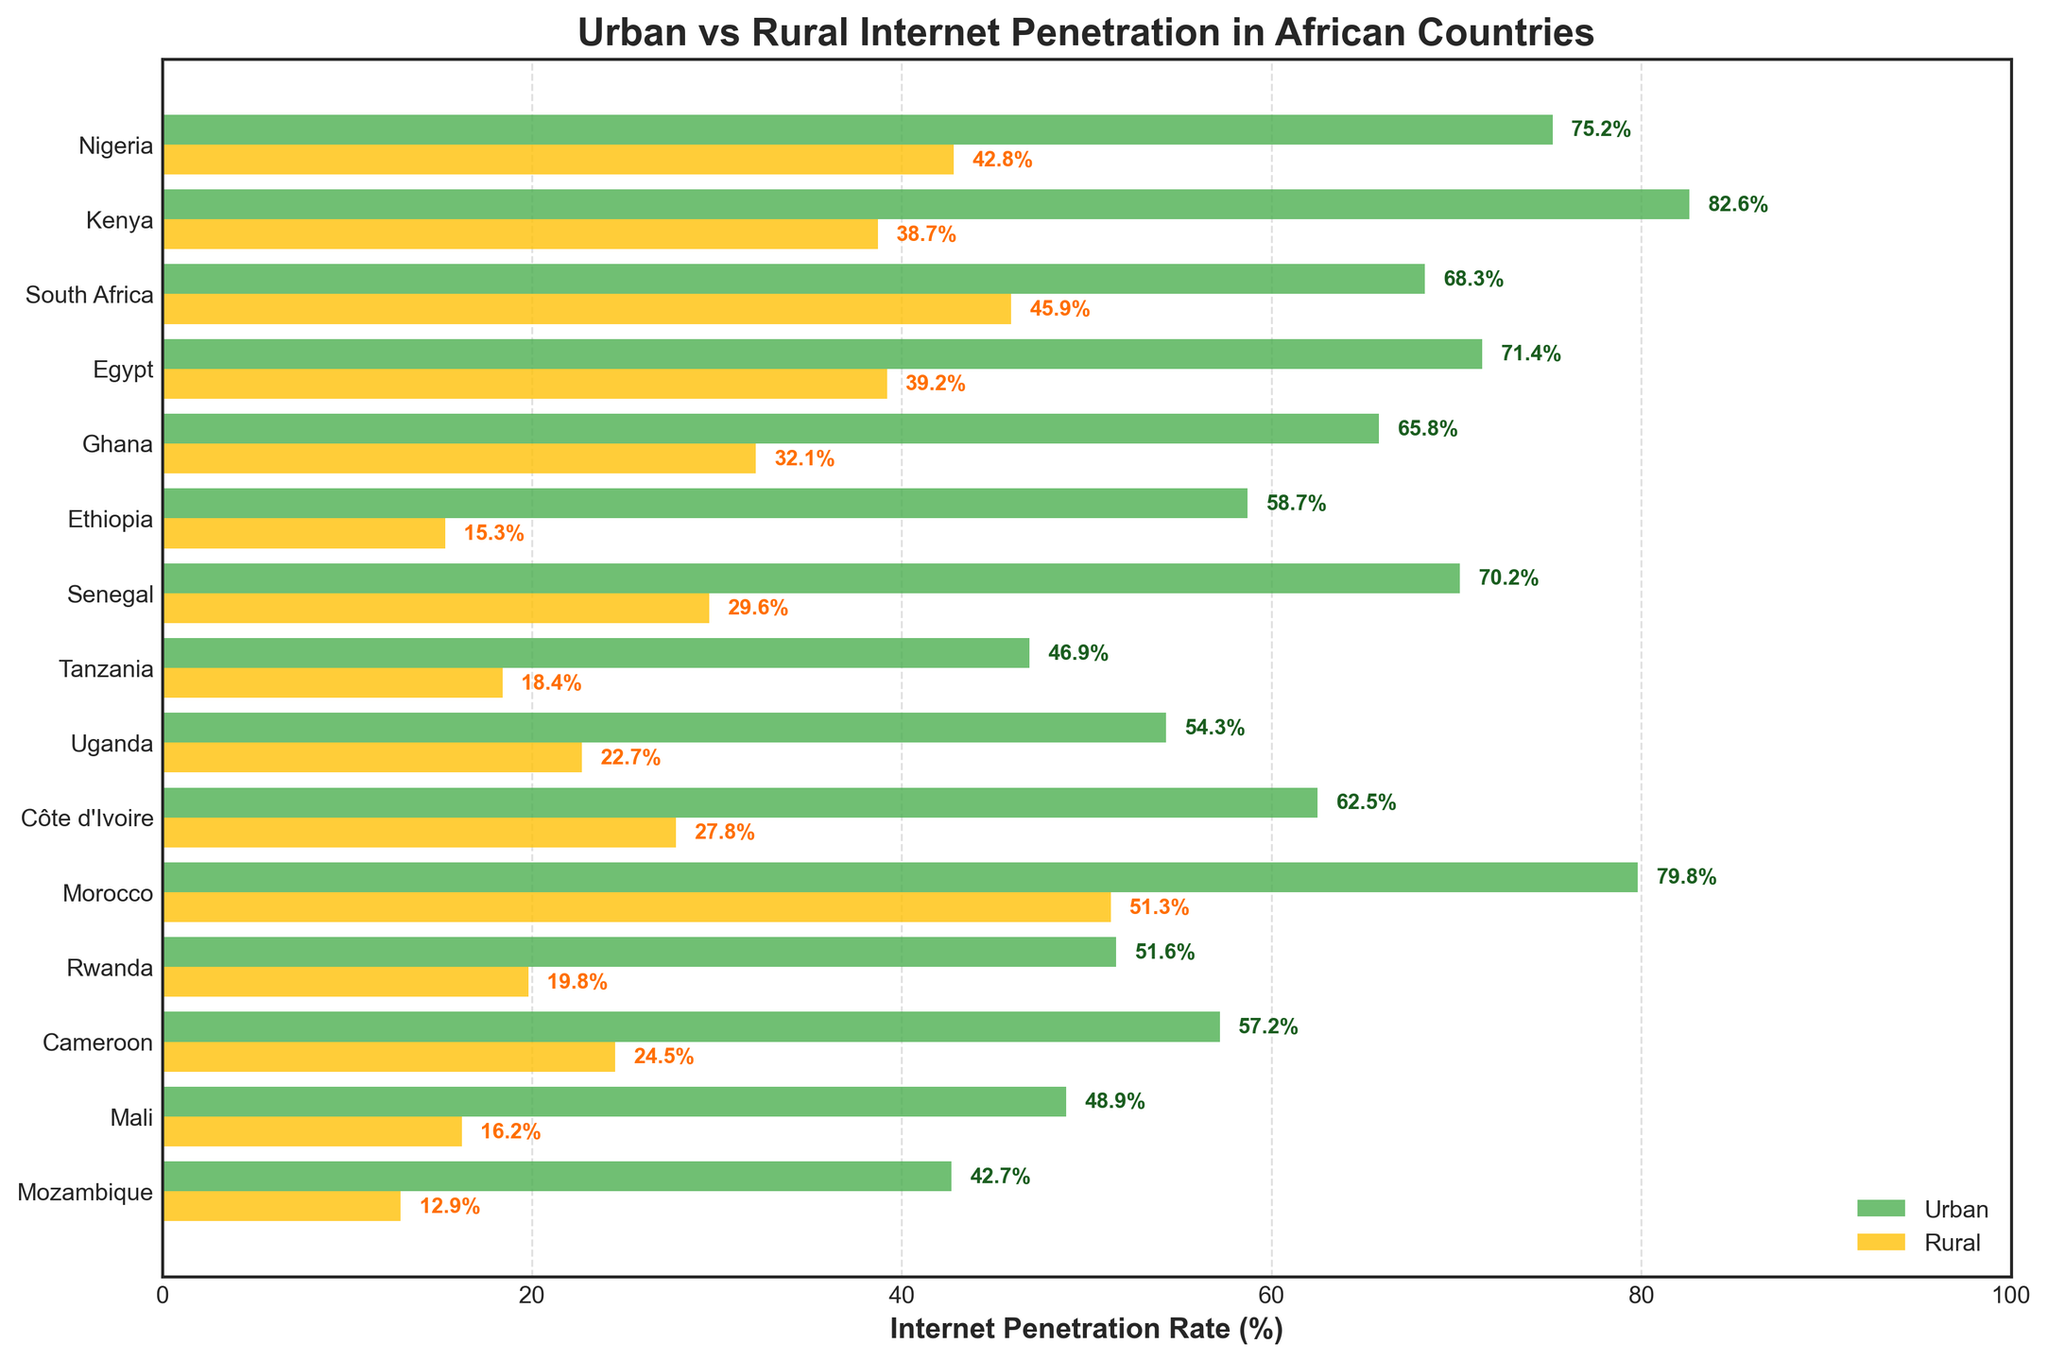What's the title of the figure? The title of the figure is usually displayed at the top of the plot. Here, the title is "Urban vs Rural Internet Penetration in African Countries."
Answer: Urban vs Rural Internet Penetration in African Countries Which country has the highest urban internet penetration rate? Look for the longest green bar (representing urban penetration) and identify its corresponding country label. Kenya has the highest urban internet penetration rate.
Answer: Kenya How does the rural internet penetration rate in Morocco compare to its urban rate? Find the bars corresponding to Morocco, and compare the lengths of the green (urban) and yellow (rural) bars. Morocco has significant urban penetration (79.8%), with rural penetration lower (51.3%).
Answer: Urban is higher than rural What is the rural internet penetration rate in Mozambique? Find the yellow bar corresponding to Mozambique and read the value at the end of the bar (12.9%)
Answer: 12.9% What is the difference in internet penetration rates between urban and rural areas in Ethiopia? Subtract the rural penetration rate from the urban penetration rate for Ethiopia: 58.7% - 15.3% = 43.4%.
Answer: 43.4% Which countries have a rural internet penetration rate below 20%? Identify the countries with yellow bars that are shorter than the 20% mark on the x-axis. Countries are Ethiopia, Tanzania, Rwanda, and Mozambique.
Answer: Ethiopia, Tanzania, Rwanda, Mozambique What is the average urban internet penetration rate across the countries? Calculate the mean of all urban penetration rates: (75.2 + 82.6 + 68.3 + 71.4 + 65.8 + 58.7 + 70.2 + 46.9 + 54.3 + 62.5 + 79.8 + 51.6 + 57.2 + 48.9 + 42.7) / 15 ≈ 62.3%.
Answer: 62.3% Which country shows the smallest gap between urban and rural internet penetration rates? Calculate the differences between urban and rural rates for each country, and find the minimum: Morocco (79.8% - 51.3% = 28.5%) shows the smallest gap.
Answer: Morocco What’s the overall trend observed in the figure regarding urban and rural internet penetration rates in African countries? Generally, urban areas have significantly higher internet penetration rates compared to rural areas across all countries.
Answer: Urban > Rural Which country has an urban penetration rate close to 70%? Find the green bar near the 70% mark: Egypt (71.4%), Ghana (65.8%), Senegal (70.2%).
Answer: Egypt, Senegal 